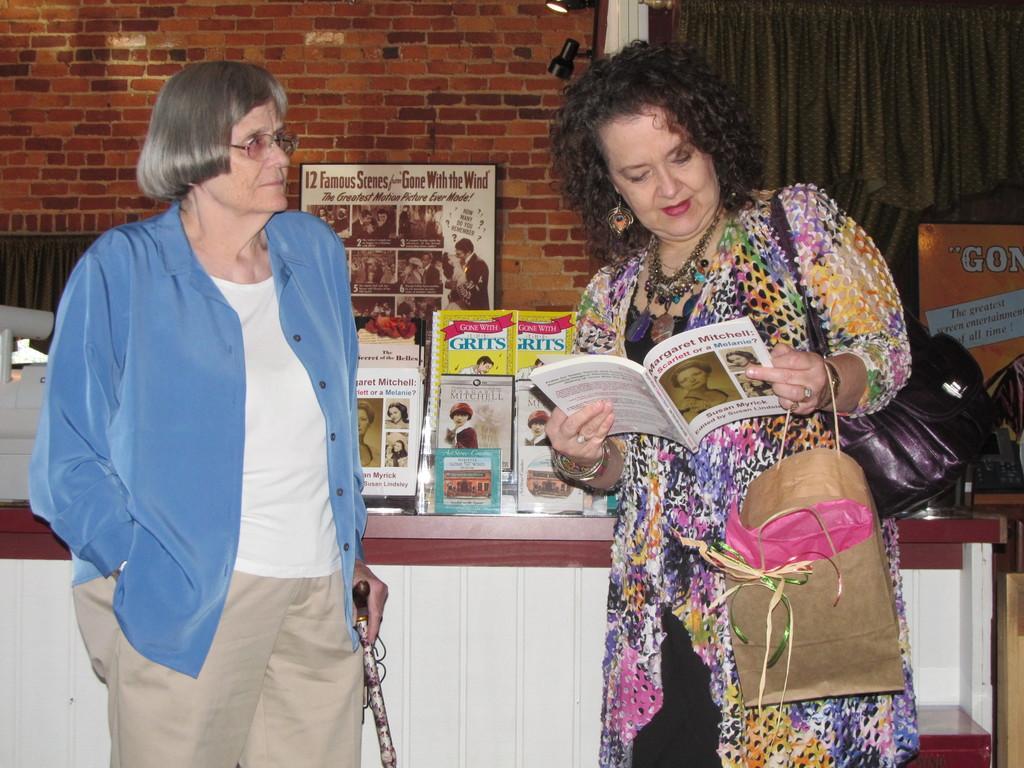In one or two sentences, can you explain what this image depicts? On the right of this picture we can see a woman wearing a sling bag, holding a bag and a book, standing and looking into the book and we can see the text and the depictions of two people on the cover of the book. On the left we can see another woman wearing shirt, holding an object and standing. In the background we can see the brick wall, wall mounted lamps, curtains, picture frame with the picture containing the text and the depictions of group of people and we can see the tables on the top of which books and some objects are placed and we can see the text and the depictions of people and the depictions of buildings and some objects on the covers of the books. In the right corner there is an object which seems to be the poster and we can see the text on the poster. 